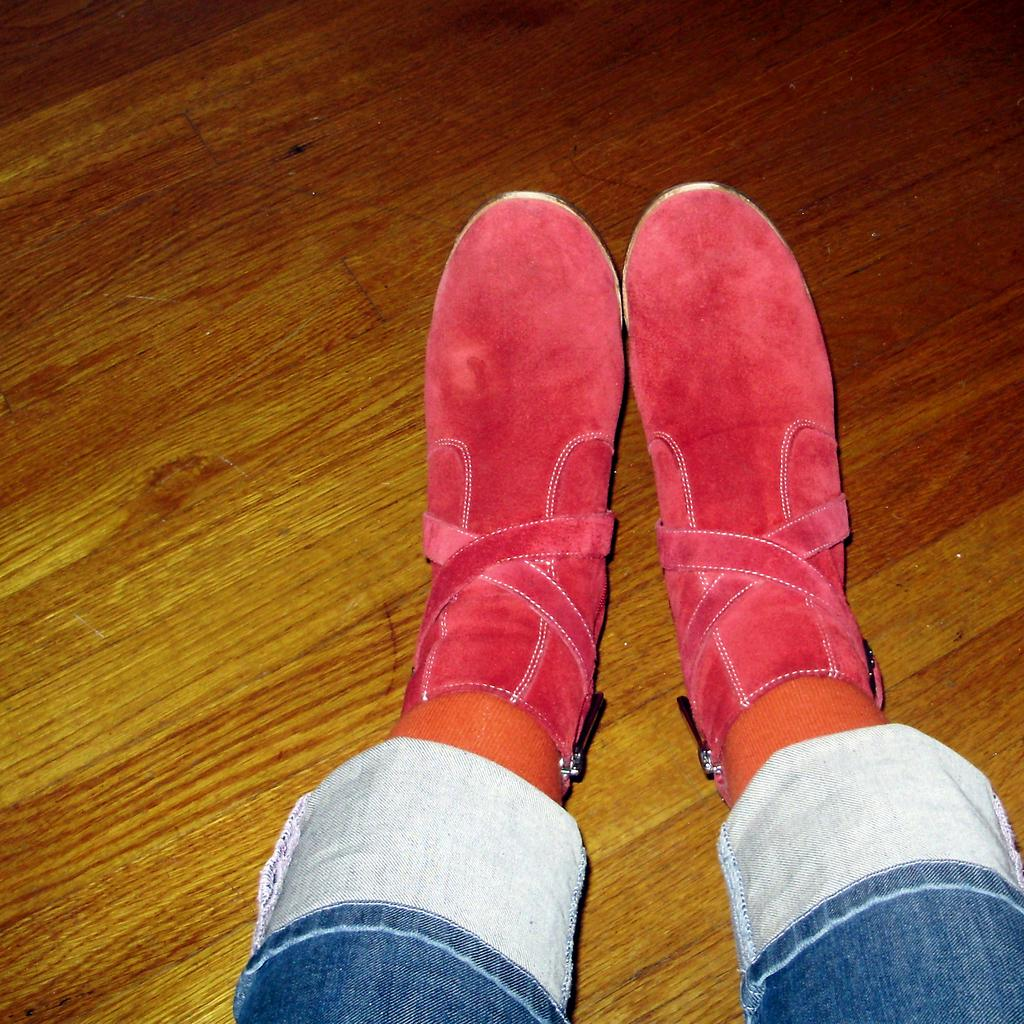What part of a person can be seen in the image? There are legs of a person visible in the image. What type of clothing is the person wearing on their feet? The person is wearing footwear in the image. Where are the legs of the person located? The legs are on the floor in the image. What songs is the zephyr playing in the image? There is no zephyr or music present in the image. What is the name of the person whose legs are visible in the image? The name of the person is not mentioned or visible in the image. 